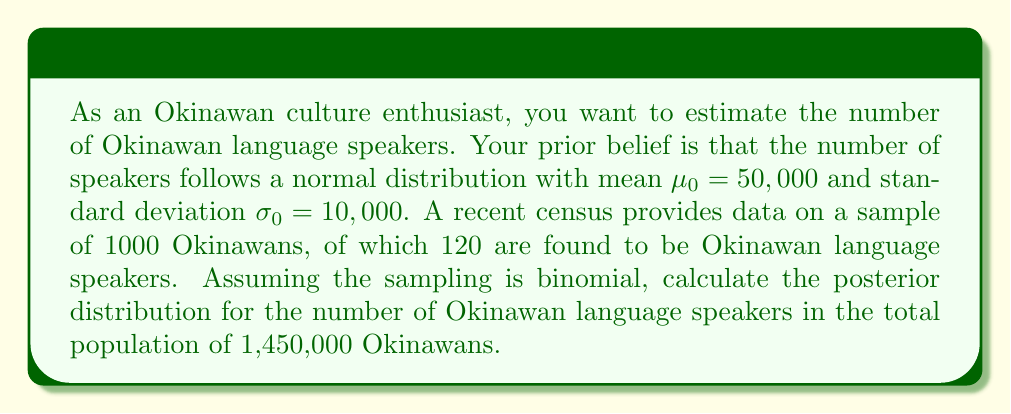Provide a solution to this math problem. Let's approach this problem step-by-step using Bayesian inference:

1) First, we need to define our variables:
   $\theta$ = proportion of Okinawan language speakers in the population
   $N$ = total population = 1,450,000
   $n$ = sample size = 1000
   $y$ = number of speakers in the sample = 120

2) Our prior belief about $\theta$ can be expressed as:
   $\theta \sim Normal(\mu_0/N, (\sigma_0/N)^2)$
   $\theta \sim Normal(0.0345, 0.0000475^2)$

3) The likelihood function, given our binomial sampling, is:
   $y|\theta \sim Binomial(n, \theta)$

4) To update our belief, we use Bayes' theorem. The posterior distribution of $\theta$ given $y$ is proportional to the product of the prior and the likelihood:

   $p(\theta|y) \propto p(\theta) \cdot p(y|\theta)$

5) When combining a normal prior with a binomial likelihood, the posterior distribution is approximately normal. We can calculate the parameters of this posterior normal distribution using the following formulas:

   $\mu_n = \frac{\frac{\mu_0}{\sigma_0^2} + \frac{y}{n/\theta(1-\theta)}}{\frac{1}{\sigma_0^2} + \frac{n}{\theta(1-\theta)}}$

   $\sigma_n^2 = \frac{1}{\frac{1}{\sigma_0^2} + \frac{n}{\theta(1-\theta)}}$

6) Substituting our values:

   $\mu_n = \frac{\frac{50000}{10000^2} + \frac{120}{1000/0.12(1-0.12)}}{\frac{1}{10000^2} + \frac{1000}{0.12(1-0.12)}} \approx 0.1214$

   $\sigma_n^2 = \frac{1}{\frac{1}{10000^2} + \frac{1000}{0.12(1-0.12)}} \approx 0.0000001$

7) Therefore, our posterior distribution for $\theta$ is:
   $\theta|y \sim Normal(0.1214, 0.0000001)$

8) To get the distribution for the number of speakers, we multiply by $N$:
   $N\theta|y \sim Normal(0.1214N, (0.0000001)N^2)$
   $N\theta|y \sim Normal(176,030, 210,250^2)$
Answer: The posterior distribution for the number of Okinawan language speakers is approximately $Normal(176,030, 210,250^2)$. 